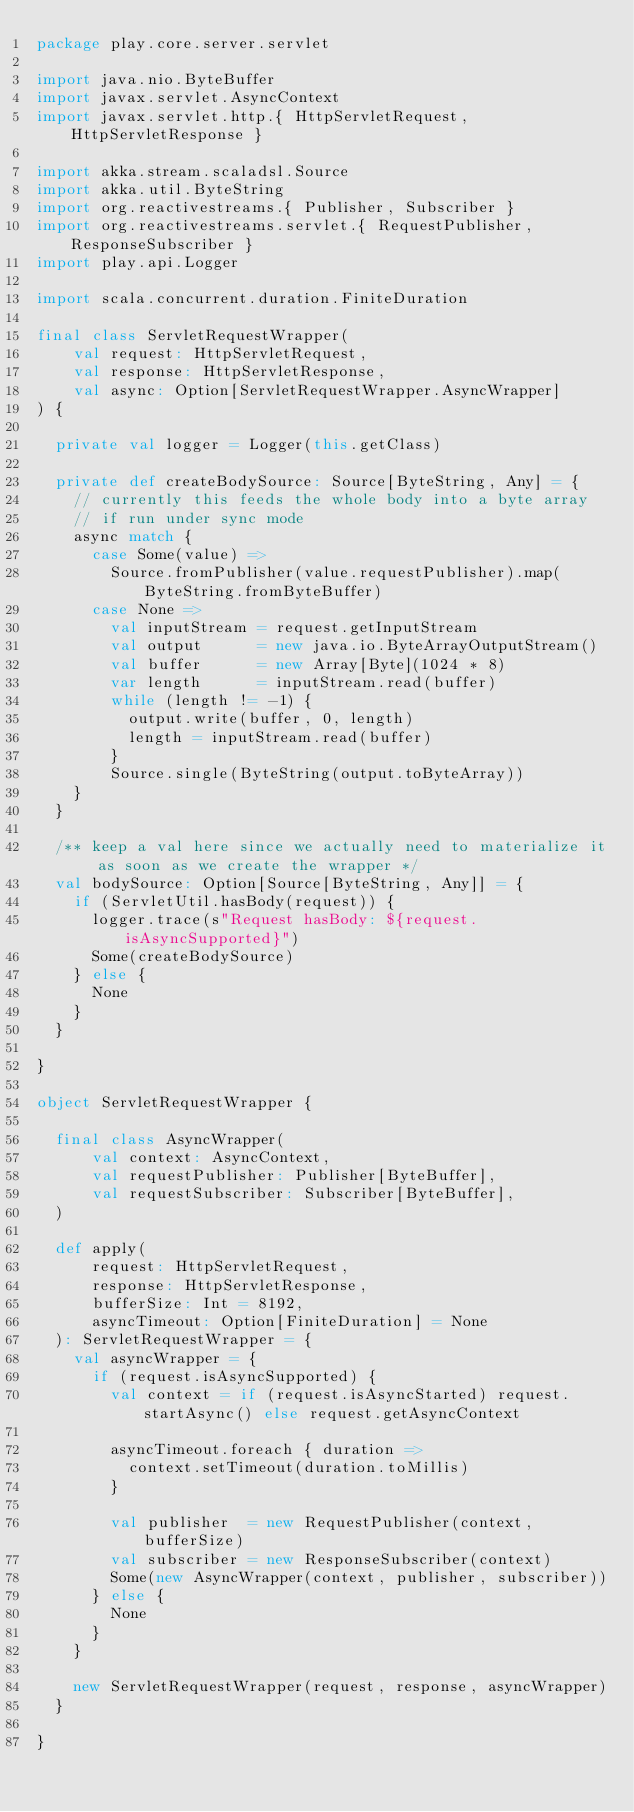Convert code to text. <code><loc_0><loc_0><loc_500><loc_500><_Scala_>package play.core.server.servlet

import java.nio.ByteBuffer
import javax.servlet.AsyncContext
import javax.servlet.http.{ HttpServletRequest, HttpServletResponse }

import akka.stream.scaladsl.Source
import akka.util.ByteString
import org.reactivestreams.{ Publisher, Subscriber }
import org.reactivestreams.servlet.{ RequestPublisher, ResponseSubscriber }
import play.api.Logger

import scala.concurrent.duration.FiniteDuration

final class ServletRequestWrapper(
    val request: HttpServletRequest,
    val response: HttpServletResponse,
    val async: Option[ServletRequestWrapper.AsyncWrapper]
) {

  private val logger = Logger(this.getClass)

  private def createBodySource: Source[ByteString, Any] = {
    // currently this feeds the whole body into a byte array
    // if run under sync mode
    async match {
      case Some(value) =>
        Source.fromPublisher(value.requestPublisher).map(ByteString.fromByteBuffer)
      case None =>
        val inputStream = request.getInputStream
        val output      = new java.io.ByteArrayOutputStream()
        val buffer      = new Array[Byte](1024 * 8)
        var length      = inputStream.read(buffer)
        while (length != -1) {
          output.write(buffer, 0, length)
          length = inputStream.read(buffer)
        }
        Source.single(ByteString(output.toByteArray))
    }
  }

  /** keep a val here since we actually need to materialize it as soon as we create the wrapper */
  val bodySource: Option[Source[ByteString, Any]] = {
    if (ServletUtil.hasBody(request)) {
      logger.trace(s"Request hasBody: ${request.isAsyncSupported}")
      Some(createBodySource)
    } else {
      None
    }
  }

}

object ServletRequestWrapper {

  final class AsyncWrapper(
      val context: AsyncContext,
      val requestPublisher: Publisher[ByteBuffer],
      val requestSubscriber: Subscriber[ByteBuffer],
  )

  def apply(
      request: HttpServletRequest,
      response: HttpServletResponse,
      bufferSize: Int = 8192,
      asyncTimeout: Option[FiniteDuration] = None
  ): ServletRequestWrapper = {
    val asyncWrapper = {
      if (request.isAsyncSupported) {
        val context = if (request.isAsyncStarted) request.startAsync() else request.getAsyncContext

        asyncTimeout.foreach { duration =>
          context.setTimeout(duration.toMillis)
        }

        val publisher  = new RequestPublisher(context, bufferSize)
        val subscriber = new ResponseSubscriber(context)
        Some(new AsyncWrapper(context, publisher, subscriber))
      } else {
        None
      }
    }

    new ServletRequestWrapper(request, response, asyncWrapper)
  }

}
</code> 